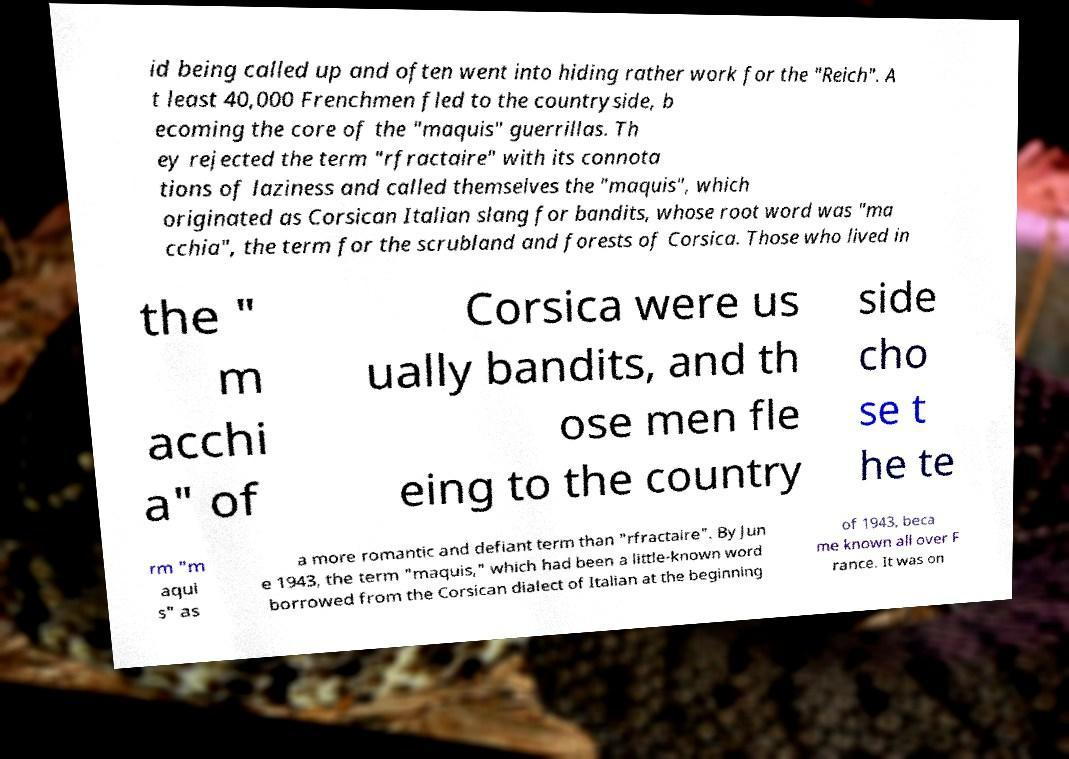I need the written content from this picture converted into text. Can you do that? id being called up and often went into hiding rather work for the "Reich". A t least 40,000 Frenchmen fled to the countryside, b ecoming the core of the "maquis" guerrillas. Th ey rejected the term "rfractaire" with its connota tions of laziness and called themselves the "maquis", which originated as Corsican Italian slang for bandits, whose root word was "ma cchia", the term for the scrubland and forests of Corsica. Those who lived in the " m acchi a" of Corsica were us ually bandits, and th ose men fle eing to the country side cho se t he te rm "m aqui s" as a more romantic and defiant term than "rfractaire". By Jun e 1943, the term "maquis," which had been a little-known word borrowed from the Corsican dialect of Italian at the beginning of 1943, beca me known all over F rance. It was on 